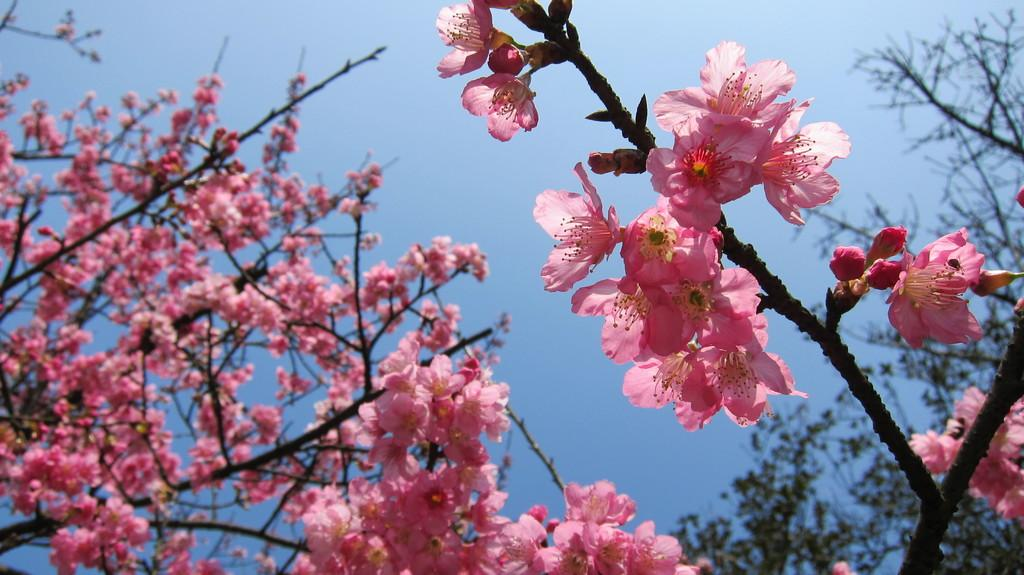What type of plant elements are present in the image? There are branches with flowers and buds in the image. What can be seen in the background of the image? There are branches of trees in the background of the image. What part of the natural environment is visible in the image? The sky is visible in the background of the image. What type of cream can be seen on the railway in the image? There is no railway or cream present in the image; it features branches with flowers and buds, as well as branches of trees in the background. 